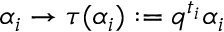Convert formula to latex. <formula><loc_0><loc_0><loc_500><loc_500>\alpha _ { i } \rightarrow \tau ( \alpha _ { i } ) \colon = q ^ { t _ { i } } \alpha _ { i } \,</formula> 